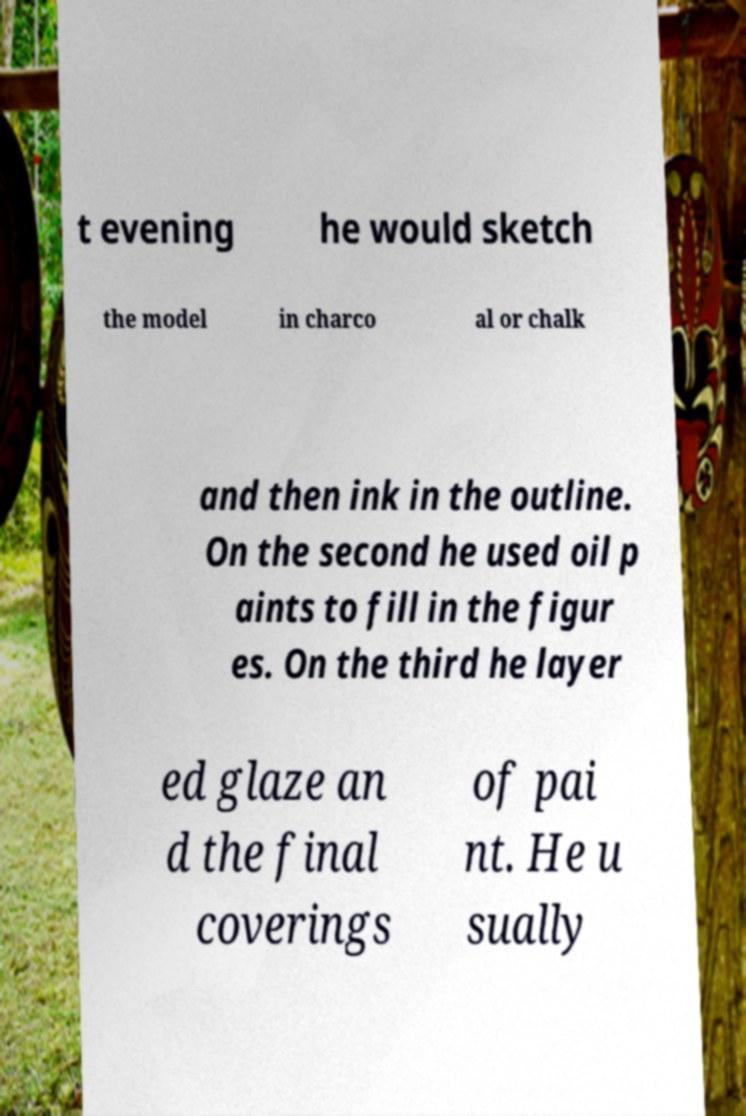Could you extract and type out the text from this image? t evening he would sketch the model in charco al or chalk and then ink in the outline. On the second he used oil p aints to fill in the figur es. On the third he layer ed glaze an d the final coverings of pai nt. He u sually 